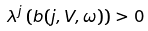Convert formula to latex. <formula><loc_0><loc_0><loc_500><loc_500>\lambda ^ { j } \left ( b ( j , V , \omega ) \right ) > 0</formula> 